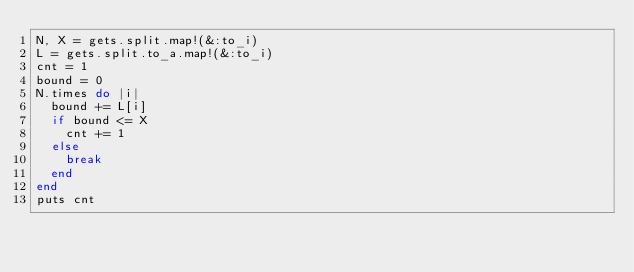Convert code to text. <code><loc_0><loc_0><loc_500><loc_500><_Ruby_>N, X = gets.split.map!(&:to_i)
L = gets.split.to_a.map!(&:to_i)
cnt = 1
bound = 0
N.times do |i|
	bound += L[i]
	if bound <= X
		cnt += 1
	else
		break
	end
end
puts cnt</code> 